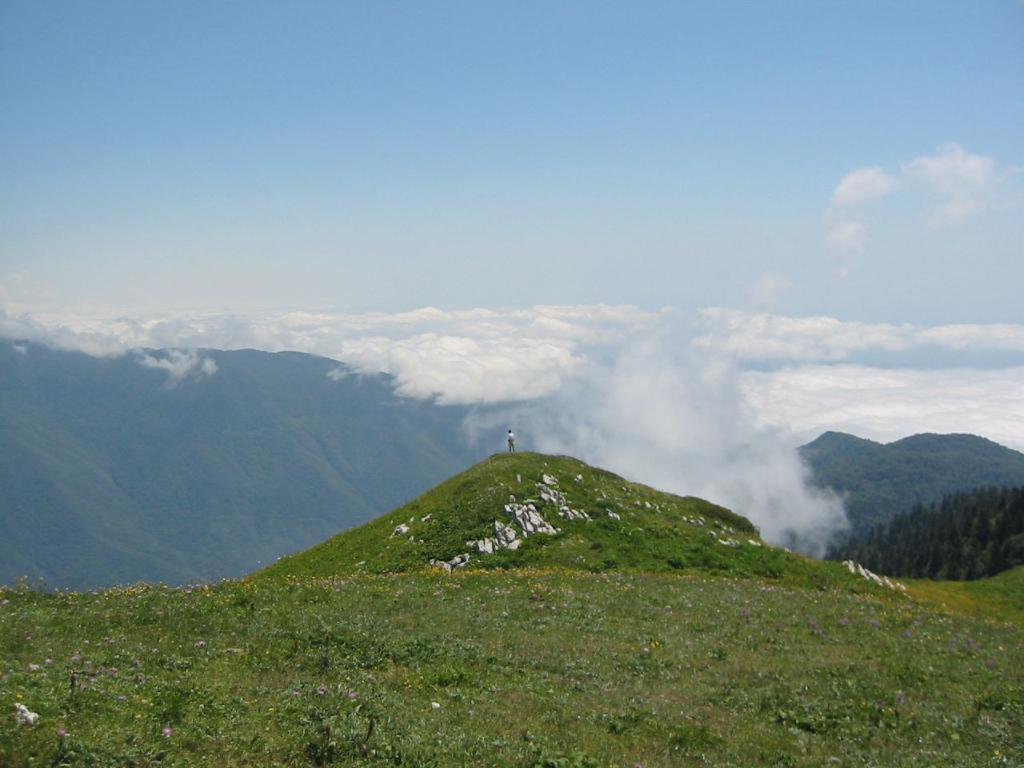What type of vegetation or plants can be seen at the bottom side of the image? There is greenery at the bottom side of the image. What is the main subject in the center of the image? There is a man standing in the center of the image. What is visible at the top side of the image? There is sky visible at the top side of the image. What invention is the man holding in his hand in the image? There is no invention visible in the man's hand in the image. How much money is the man holding in the image? There is no money visible in the man's hand in the image. 